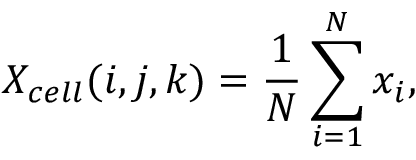<formula> <loc_0><loc_0><loc_500><loc_500>{ X _ { c e l l } } ( i , j , k ) = \frac { 1 } { N } \sum _ { i = 1 } ^ { N } x _ { i } ,</formula> 